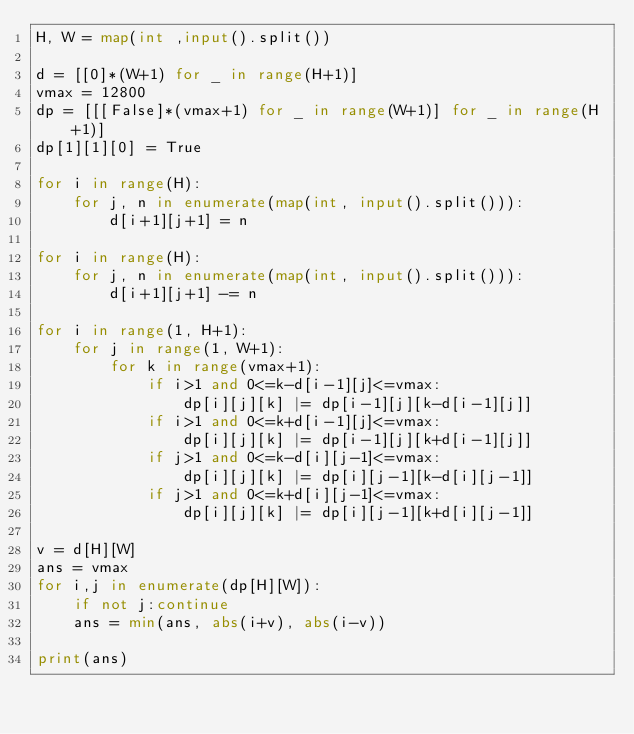<code> <loc_0><loc_0><loc_500><loc_500><_Python_>H, W = map(int ,input().split())

d = [[0]*(W+1) for _ in range(H+1)]
vmax = 12800
dp = [[[False]*(vmax+1) for _ in range(W+1)] for _ in range(H+1)]
dp[1][1][0] = True

for i in range(H):
    for j, n in enumerate(map(int, input().split())):
        d[i+1][j+1] = n
    
for i in range(H):
    for j, n in enumerate(map(int, input().split())):
        d[i+1][j+1] -= n

for i in range(1, H+1):
    for j in range(1, W+1):
        for k in range(vmax+1):
            if i>1 and 0<=k-d[i-1][j]<=vmax:
                dp[i][j][k] |= dp[i-1][j][k-d[i-1][j]]
            if i>1 and 0<=k+d[i-1][j]<=vmax:
                dp[i][j][k] |= dp[i-1][j][k+d[i-1][j]]
            if j>1 and 0<=k-d[i][j-1]<=vmax:
                dp[i][j][k] |= dp[i][j-1][k-d[i][j-1]]
            if j>1 and 0<=k+d[i][j-1]<=vmax:
                dp[i][j][k] |= dp[i][j-1][k+d[i][j-1]]

v = d[H][W]
ans = vmax
for i,j in enumerate(dp[H][W]):
    if not j:continue
    ans = min(ans, abs(i+v), abs(i-v))

print(ans)</code> 